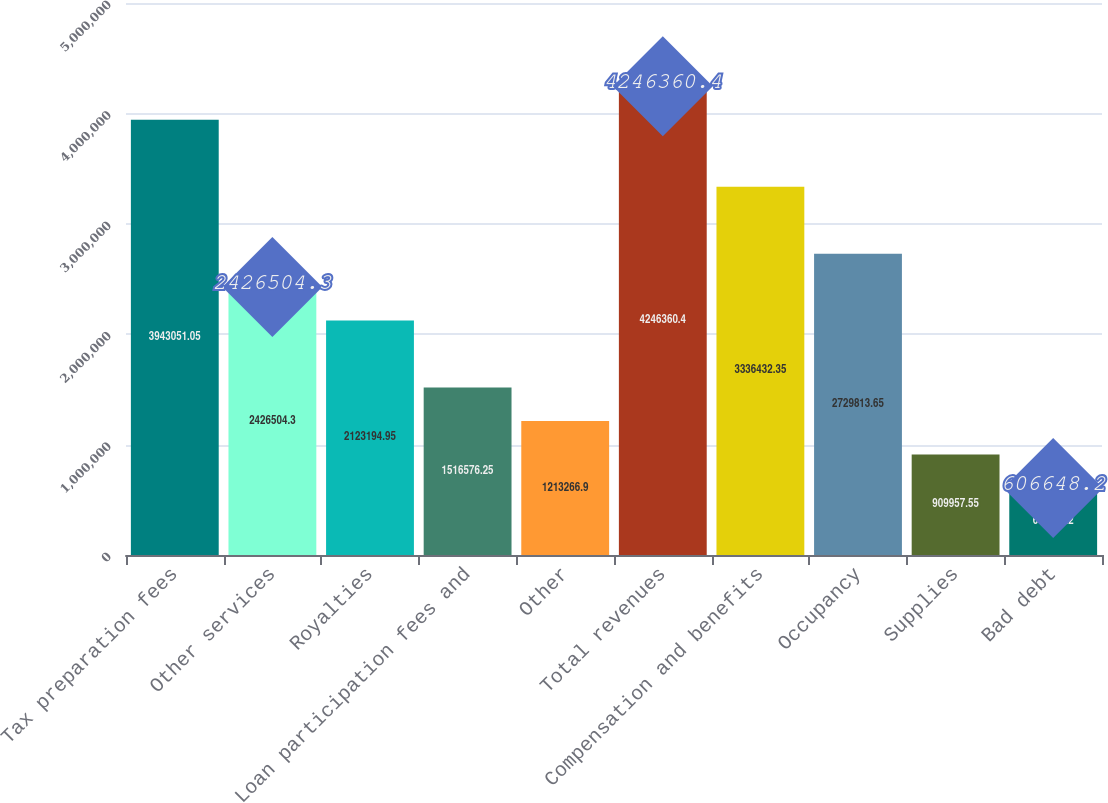Convert chart to OTSL. <chart><loc_0><loc_0><loc_500><loc_500><bar_chart><fcel>Tax preparation fees<fcel>Other services<fcel>Royalties<fcel>Loan participation fees and<fcel>Other<fcel>Total revenues<fcel>Compensation and benefits<fcel>Occupancy<fcel>Supplies<fcel>Bad debt<nl><fcel>3.94305e+06<fcel>2.4265e+06<fcel>2.12319e+06<fcel>1.51658e+06<fcel>1.21327e+06<fcel>4.24636e+06<fcel>3.33643e+06<fcel>2.72981e+06<fcel>909958<fcel>606648<nl></chart> 